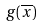Convert formula to latex. <formula><loc_0><loc_0><loc_500><loc_500>g ( \overline { x } )</formula> 